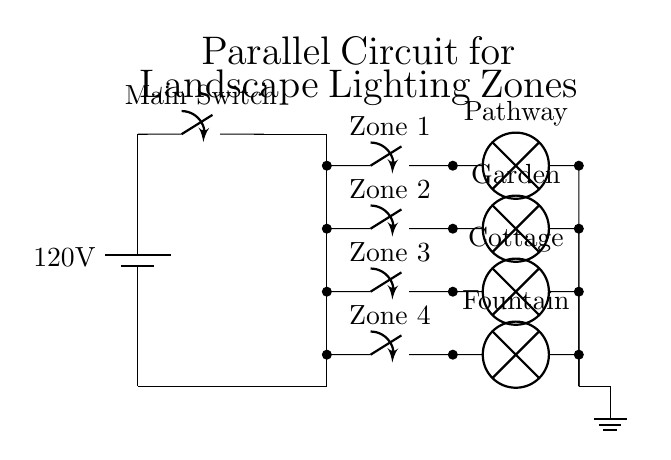What is the voltage of the power source? The diagram shows a battery labeled with a voltage of 120 volts, which is the source voltage for the circuit.
Answer: 120 volts What are the types of lights in this circuit? The circuit has four distinct types of lights: Pathway, Garden, Cottage, and Fountain. These are labeled next to their corresponding switches and components.
Answer: Pathway, Garden, Cottage, Fountain How many lighting zones are in this parallel circuit? There are four lighting zones indicated in the circuit diagram, each with its own switch, allowing for independent control.
Answer: Four What is the purpose of the main switch? The main switch is used to control the entire circuit, allowing the owner to turn all the lighting zones on or off collectively.
Answer: Control all lights How are the lights configured in this circuit? The lights are connected in a parallel configuration, meaning each lighting zone operates independently of the others, maintaining the same voltage while allowing individual control.
Answer: In parallel What would happen if one zone's lights fail? If one zone's lights fail, it would not affect the other zones because they are wired in parallel, allowing them to function independently.
Answer: Others remain operational 